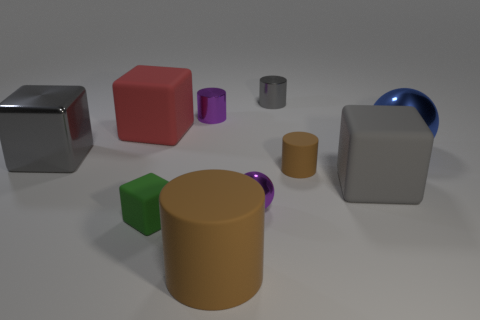What material is the large ball?
Keep it short and to the point. Metal. What is the shape of the gray thing that is the same material as the big cylinder?
Make the answer very short. Cube. There is a gray metallic thing behind the block that is on the left side of the red matte thing; how big is it?
Your response must be concise. Small. There is a large matte block in front of the small brown matte cylinder; what color is it?
Make the answer very short. Gray. Is there a brown metallic thing that has the same shape as the gray rubber thing?
Offer a terse response. No. Are there fewer large gray metal objects that are in front of the large gray metallic object than big cubes to the left of the small green rubber object?
Keep it short and to the point. Yes. What is the color of the large metal sphere?
Ensure brevity in your answer.  Blue. Is there a tiny cylinder that is in front of the rubber object that is behind the large blue shiny object?
Your answer should be very brief. Yes. How many gray rubber cubes are the same size as the gray shiny cube?
Provide a succinct answer. 1. There is a large gray object that is behind the big gray cube on the right side of the tiny brown matte cylinder; what number of gray objects are on the right side of it?
Your answer should be compact. 2. 